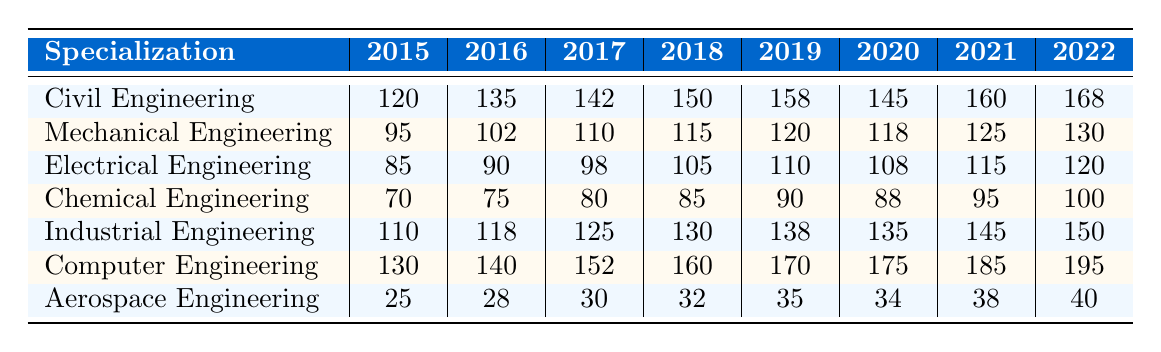What was the highest number of graduates in Computer Engineering, and in which year? Referring to the table, the highest number of graduates in Computer Engineering is 195, which occurs in the year 2022.
Answer: 195 in 2022 Which specialization had the lowest number of graduates in 2015? Looking at the table, in 2015, Aerospace Engineering had the lowest number of graduates at 25 compared to other specializations.
Answer: Aerospace Engineering with 25 What is the average number of graduates for Civil Engineering from 2015 to 2022? Summing the number of graduates from 2015 to 2022 for Civil Engineering gives (120 + 135 + 142 + 150 + 158 + 145 + 160 + 168) = 1,078. There are 8 years, so the average is 1,078 / 8 = 134.75.
Answer: 134.75 Did the employment rate for Mechanical Engineering increase every year from 2015 to 2022? Checking the table for Mechanical Engineering, the employment rates for each year are 90, 91, 92, 93, 94, 92, 93, 94. The rates did not increase every year since there is a drop in 2020.
Answer: No Which specialization had the highest average salary over the years 2015-2022? Calculating the average salary for each specialization: Civil Engineering = 43000, Mechanical Engineering = 44000, Electrical Engineering = 44500, Chemical Engineering = 41500, Industrial Engineering = 44500, Computer Engineering = 46500, and Aerospace Engineering = 39500. The highest is Computer Engineering at 46500.
Answer: Computer Engineering with 46500 What was the percentage increase in graduates for Industrial Engineering from 2015 to 2022? From the table, the number of graduates in Industrial Engineering increased from 110 in 2015 to 150 in 2022. The increase is 150 - 110 = 40, and the percentage increase is (40 / 110) * 100 = 36.36%.
Answer: 36.36% In what year did Electrical Engineering have its highest employment rate? According to the table, Electrical Engineering had its highest employment rate of 95% in 2019 and 2022.
Answer: 2019 and 2022 How many more graduates did Computer Engineering have than Chemical Engineering in 2019? For 2019, Computer Engineering had 170 graduates and Chemical Engineering had 90 graduates. The difference is 170 - 90 = 80.
Answer: 80 Was the trend for graduates in Aerospace Engineering upward from 2015 to 2022? Checking the Aerospace Engineering graduates: 25 in 2015, 28 in 2016, 30 in 2017, 32 in 2018, 35 in 2019, 34 in 2020, 38 in 2021, and 40 in 2022. The values show an increase overall, despite one year having a drop.
Answer: No, it wasn't consistently upward What is the total number of graduates from all specializations in 2020? Adding the number of graduates from all specializations in 2020: 145 (Civil) + 118 (Mechanical) + 108 (Electrical) + 88 (Chemical) + 135 (Industrial) + 175 (Computer) + 34 (Aerospace) gives a total of 908 graduates.
Answer: 908 